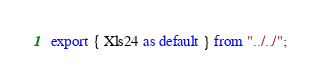Convert code to text. <code><loc_0><loc_0><loc_500><loc_500><_TypeScript_>export { Xls24 as default } from "../../";
</code> 